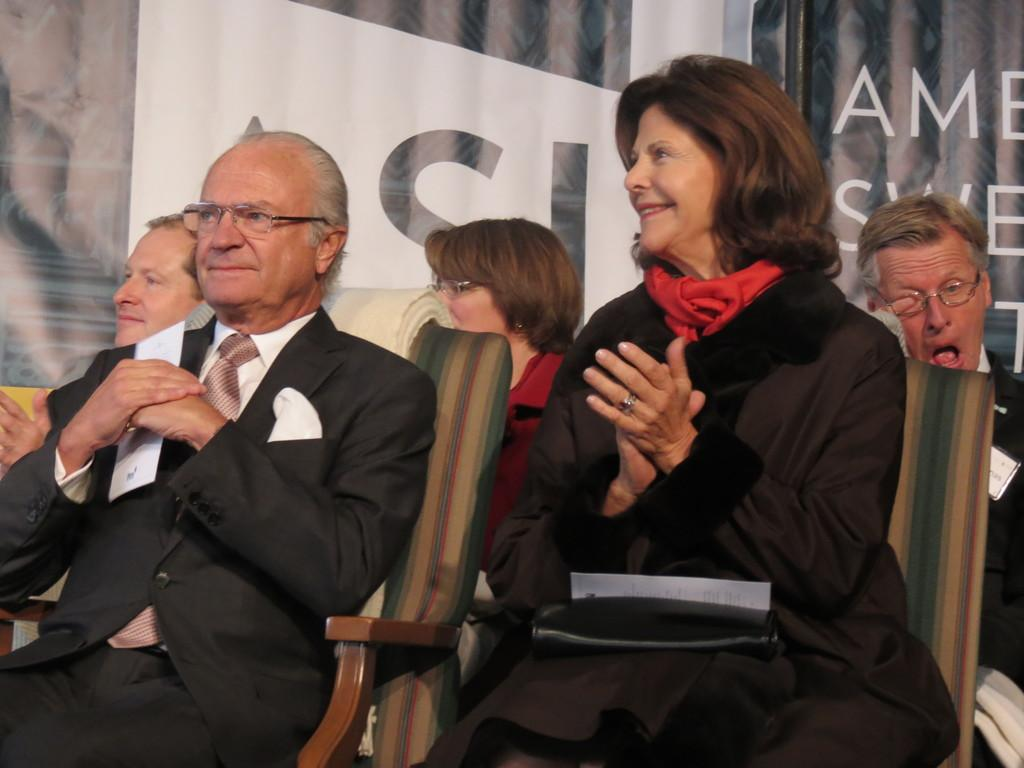What are the people in the image doing? The people in the image are sitting on chairs. Can you describe the background of the image? There is text visible in the background of the image. What type of ball is being used by the people in the image? There is no ball present in the image; the people are sitting on chairs. 